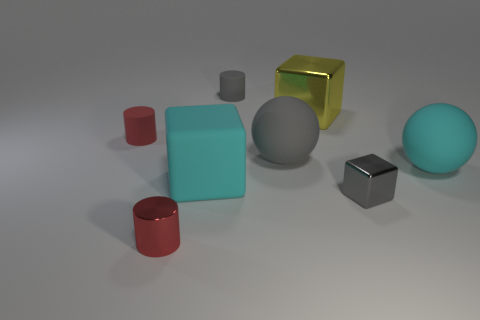Subtract all cyan blocks. How many blocks are left? 2 Add 2 small green metal cubes. How many objects exist? 10 Subtract 1 cubes. How many cubes are left? 2 Subtract all cyan cubes. How many cubes are left? 2 Subtract all blocks. How many objects are left? 5 Subtract all yellow spheres. How many blue blocks are left? 0 Subtract all green shiny blocks. Subtract all big gray objects. How many objects are left? 7 Add 1 small gray blocks. How many small gray blocks are left? 2 Add 6 cyan rubber cubes. How many cyan rubber cubes exist? 7 Subtract 0 yellow cylinders. How many objects are left? 8 